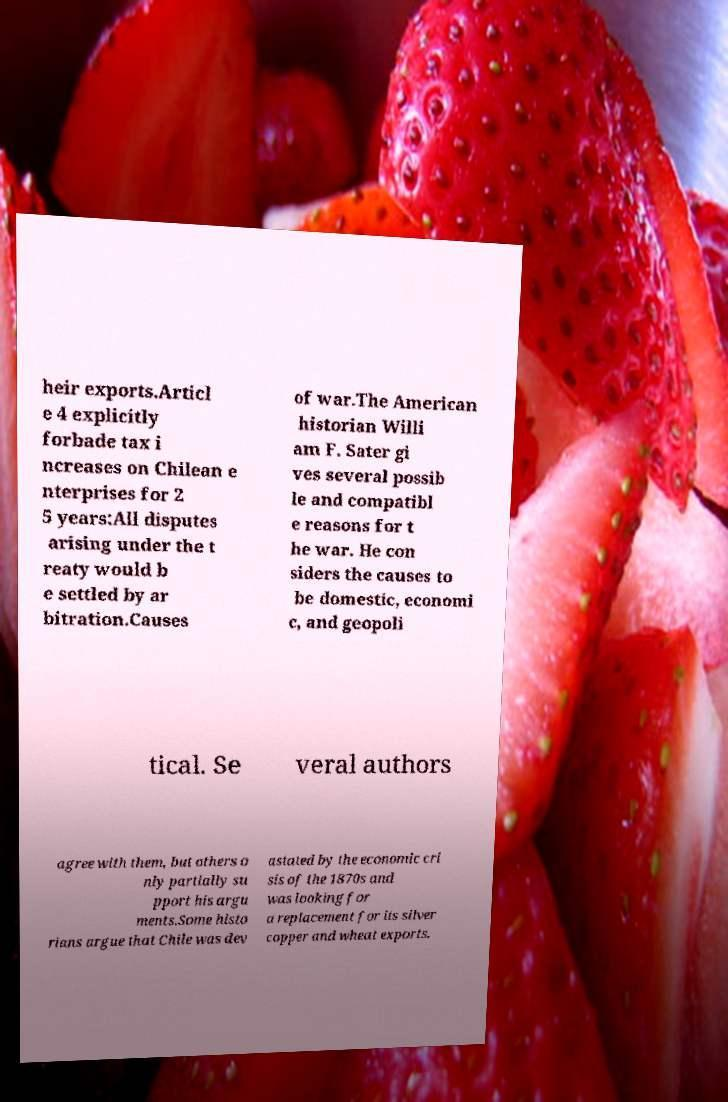Please identify and transcribe the text found in this image. heir exports.Articl e 4 explicitly forbade tax i ncreases on Chilean e nterprises for 2 5 years:All disputes arising under the t reaty would b e settled by ar bitration.Causes of war.The American historian Willi am F. Sater gi ves several possib le and compatibl e reasons for t he war. He con siders the causes to be domestic, economi c, and geopoli tical. Se veral authors agree with them, but others o nly partially su pport his argu ments.Some histo rians argue that Chile was dev astated by the economic cri sis of the 1870s and was looking for a replacement for its silver copper and wheat exports. 